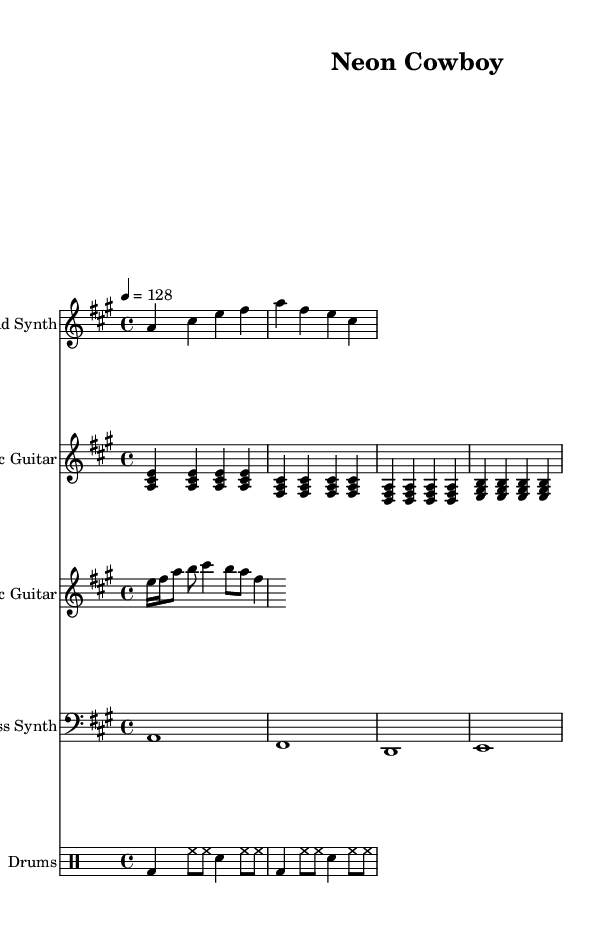What is the key signature of this music? The key signature has three sharps, which indicates that the key is A major.
Answer: A major What is the time signature of the piece? The time signature indicated in the music is 4/4, which means there are four beats in each measure.
Answer: 4/4 What is the tempo marking of the composition? The tempo marking indicates a speed of 128 beats per minute, which is a moderate tempo suitable for modern country rock.
Answer: 128 How many measures are in the lead synth part? The lead synth part consists of two measures, identifiable by the groupings of notes.
Answer: 2 What is the rhythmic pattern of the drums in the first two measures? The drum part starts with a bass drum on the first beat, followed by hi-hat eighth notes, and a snare drum on the third beat. This creates a consistent backbeat.
Answer: Bass drum with hi-hat and snare Which instrument plays the first note of the piece? The first note played is an A, which is featured prominently in the lead synth part.
Answer: Lead Synth How does the bass synth part structure its notes? The bass synth plays whole notes in a repeating pattern through the measures, each representing a single beat for the entire measure.
Answer: Whole notes 